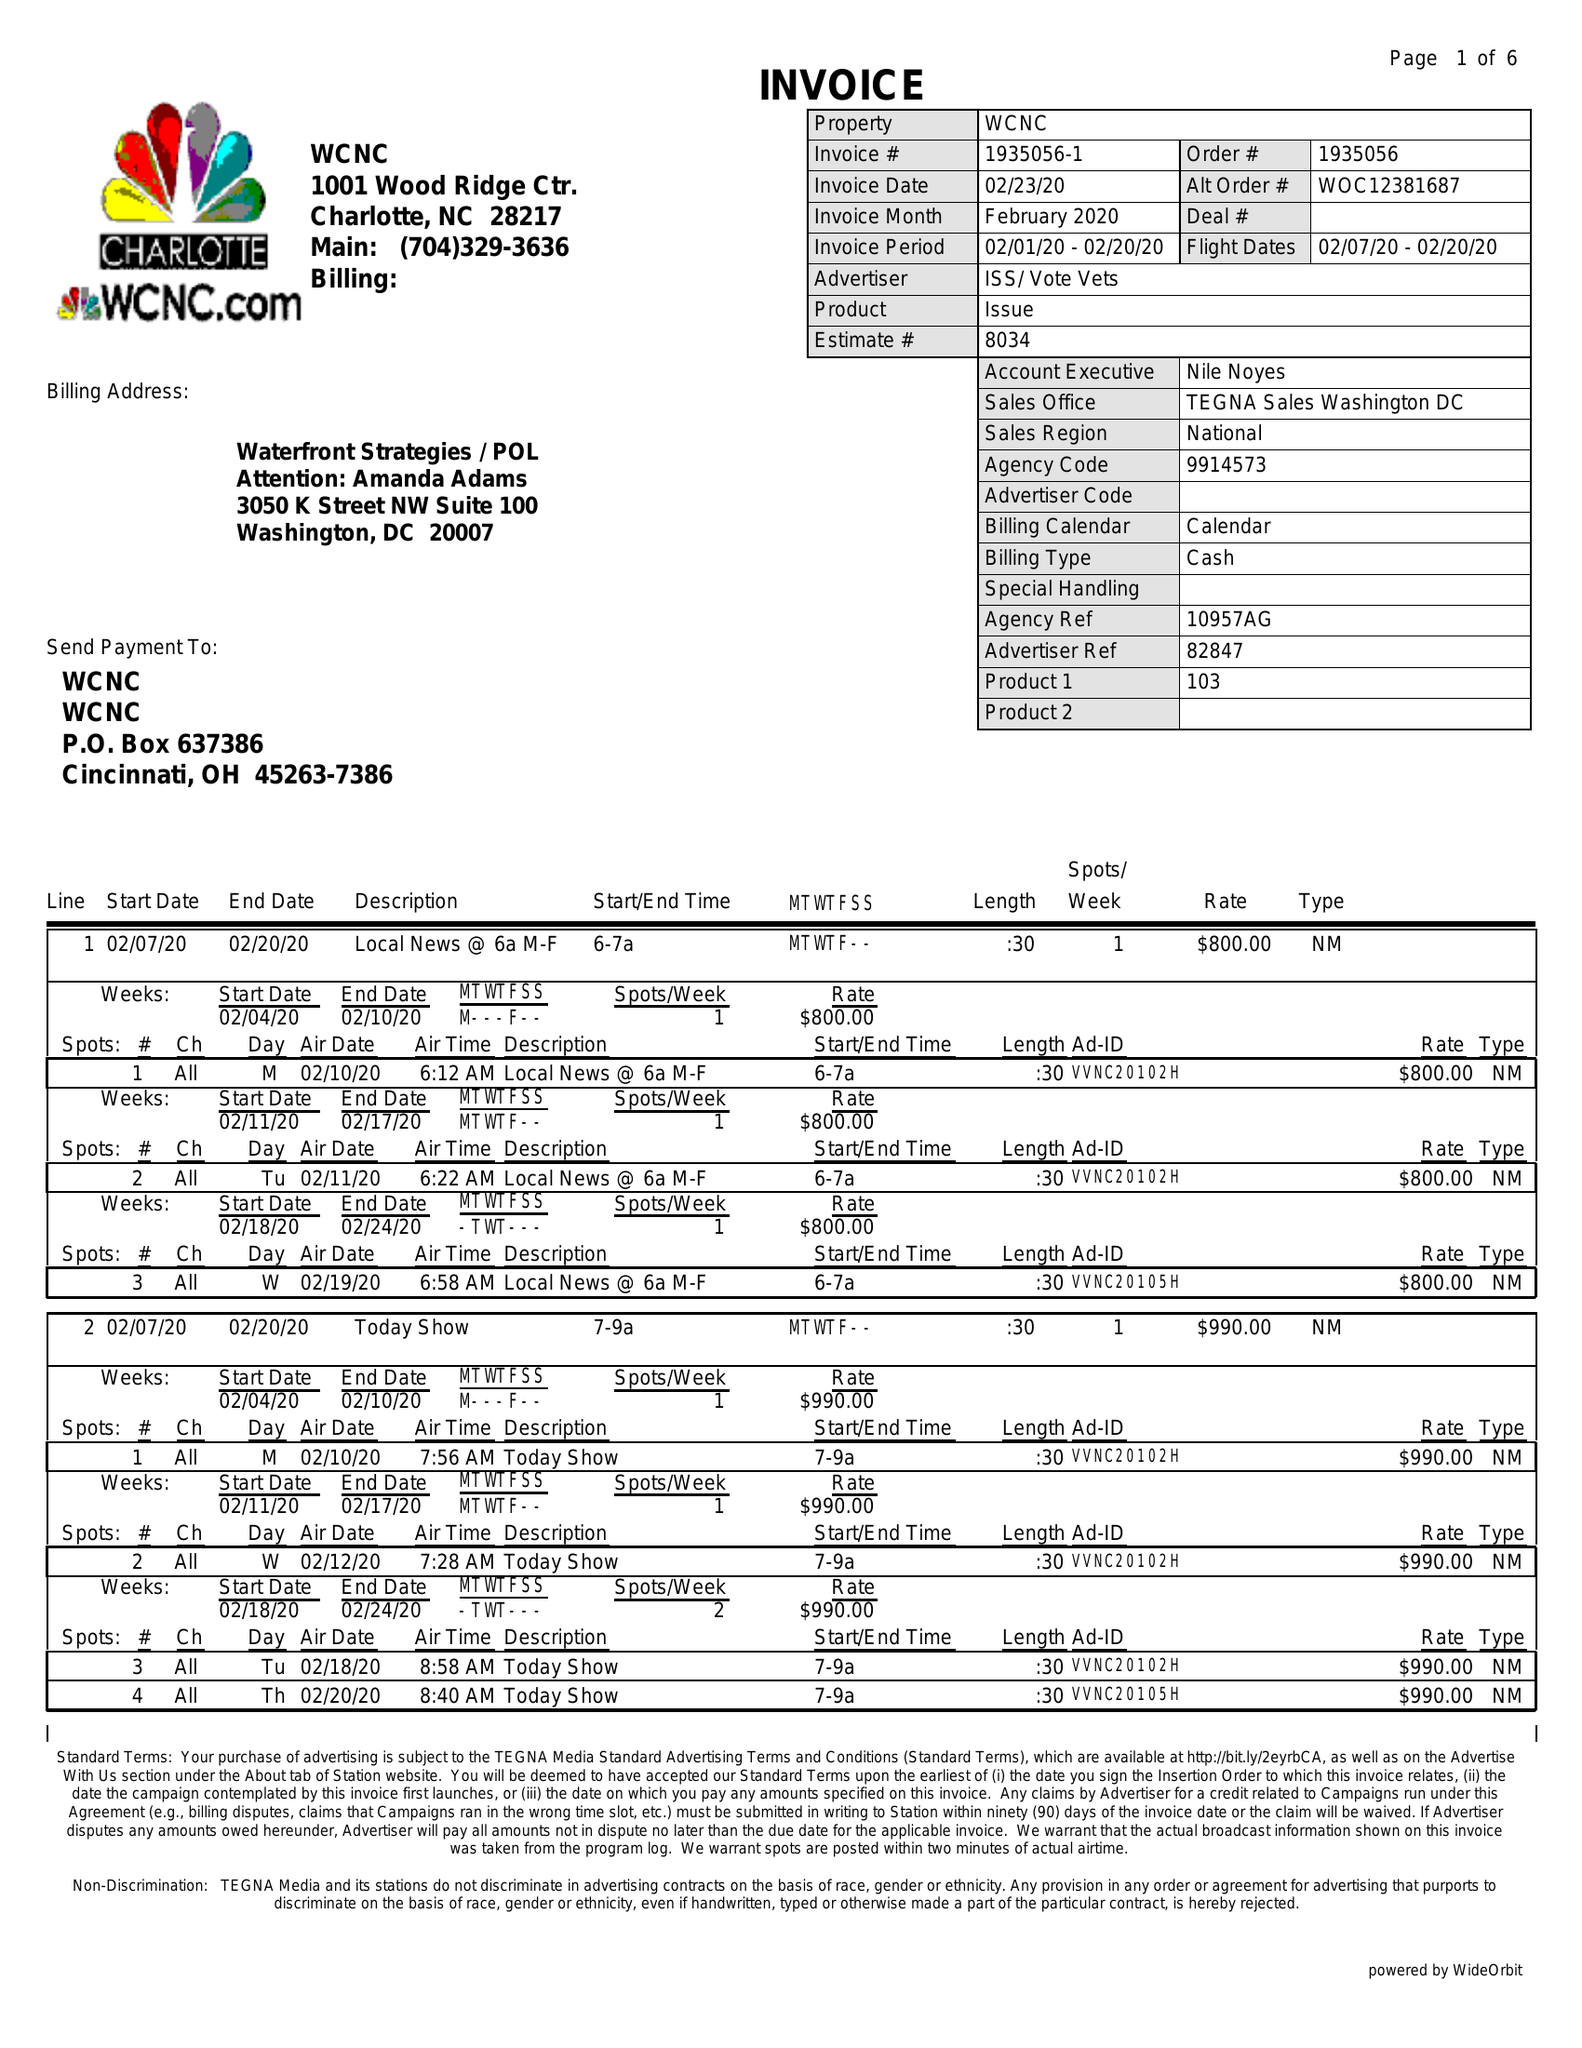What is the value for the flight_from?
Answer the question using a single word or phrase. 02/07/20 